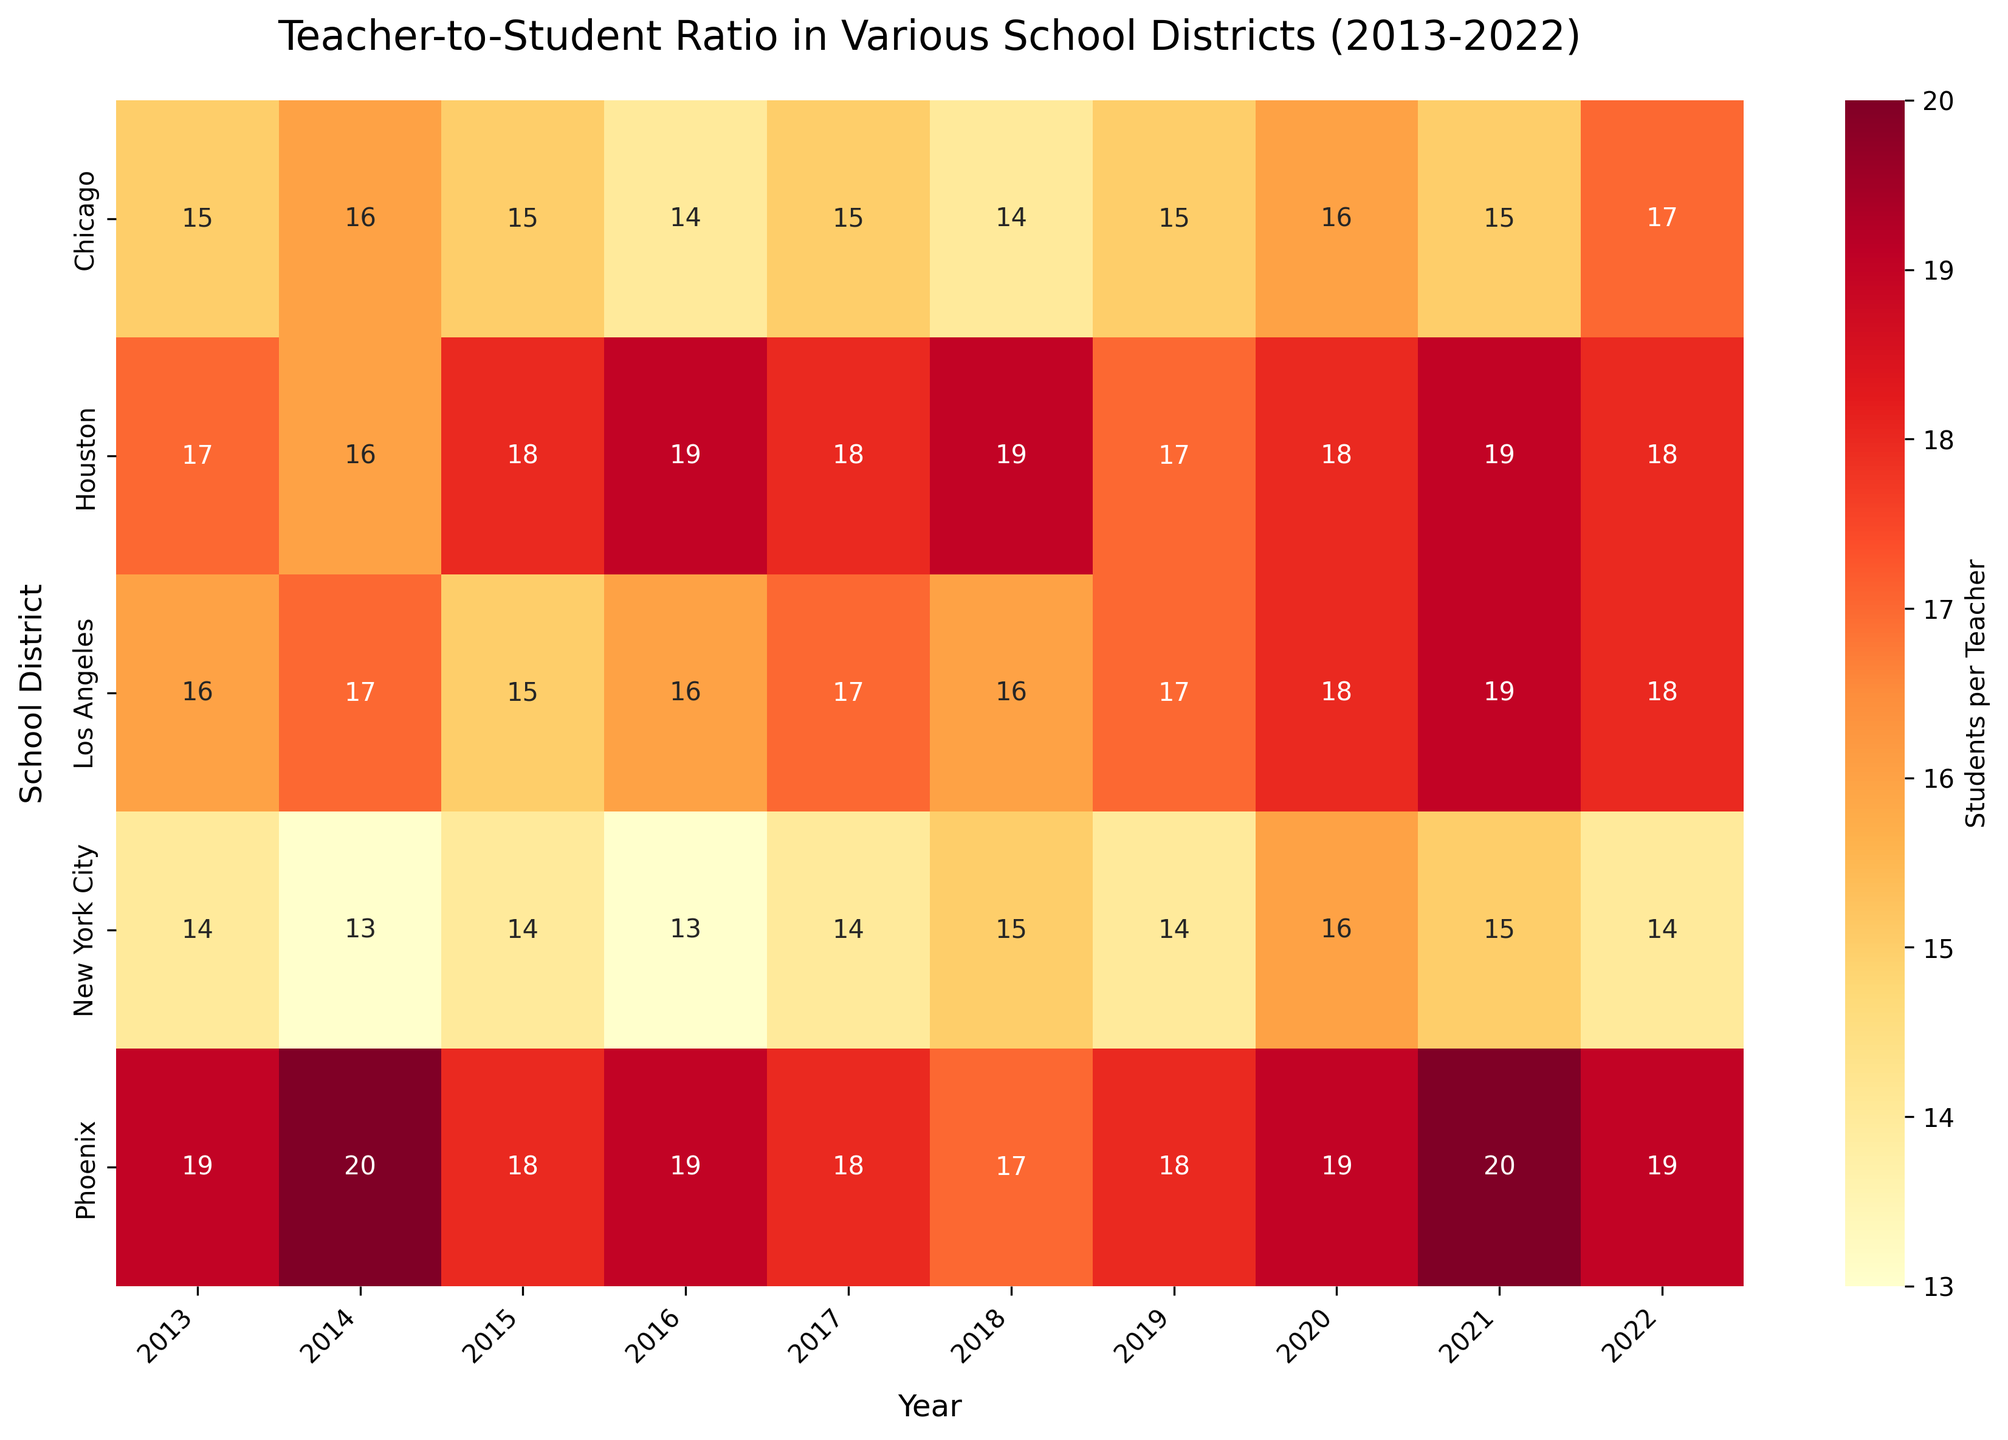What is the average teacher-to-student ratio for New York City over the decade? To find the average, sum the values for each year and divide by the number of years. For New York City, the values are 14, 13, 14, 13, 14, 15, 14, 16, 15, 14. Sum = 142. There are 10 years, so the average is 142 / 10.
Answer: 14.2 Which district had the highest teacher-to-student ratio in 2020? Look at the values for the year 2020 across all districts. The ratios are: New York City (16), Los Angeles (18), Chicago (16), Houston (18), Phoenix (19). The highest value is 19, found in Phoenix.
Answer: Phoenix How did the teacher-to-student ratio change for Los Angeles from 2013 to 2022? To see the change, compare the ratio in 2013 (16) with the ratio in 2022 (18). Subtract the 2013 ratio from the 2022 ratio (18 - 16).
Answer: Increased by 2 Which year had the lowest teacher-to-student ratio for Chicago? Examine the values for Chicago across all years and identify the smallest number. The values are: 15, 16, 15, 14, 15, 14, 15, 16, 15, 17. The lowest value is 14, found in 2016 and 2018.
Answer: 2016 and 2018 Which district shows a consistent increase in the teacher-to-student ratio over the decade? Identify which district shows a year-by-year increase without any decrease over the decade. This is found by checking if every subsequent year is higher than or equal to the previous year. Houston increases inconsistently, while Phoenix consistently increases except for two years. No district shows a strict consistent increase.
Answer: None What is the overall trend of teacher-to-student ratios in Phoenix from 2013 to 2022? Observe the changes in values for Phoenix over the years: 19, 20, 18, 19, 18, 17, 18, 19, 20, 19. Overall, there is a fluctuating trend with an initial increase, some decreases, and then rises again.
Answer: Fluctuating Which district had the lowest ratio in 2017? Look at the ratios for 2017 across all districts. New York City (14), Los Angeles (17), Chicago (15), Houston (18), Phoenix (18). The lowest value is 14 in New York City.
Answer: New York City How does the teacher-to-student ratio for Houston in 2022 compare to its ratio in 2013? Compare the ratios for Houston in 2022 (18) and 2013 (17). Subtract to find the difference: 18 - 17.
Answer: Increased by 1 What is the range of teacher-to-student ratios for Los Angeles over the decade? To find the range, identify the highest and lowest values for Los Angeles over the years: 19 in 2021 and 15 in 2015. Subtract the lowest from the highest: 19 - 15.
Answer: 4 Is there a district that has a lower teacher-to-student ratio in 2022 compared to 2020? Compare the 2022 and 2020 ratios for each district: New York City (16 in 2020, 14 in 2022), Los Angeles (18 in 2020, 18 in 2022), Chicago (16 in 2020, 17 in 2022), Houston (18 in 2020, 18 in 2022), Phoenix (19 in 2020, 19 in 2022). New York City's ratio decreases.
Answer: New York City 